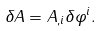Convert formula to latex. <formula><loc_0><loc_0><loc_500><loc_500>\delta A = A _ { , i } \delta \varphi ^ { i } .</formula> 